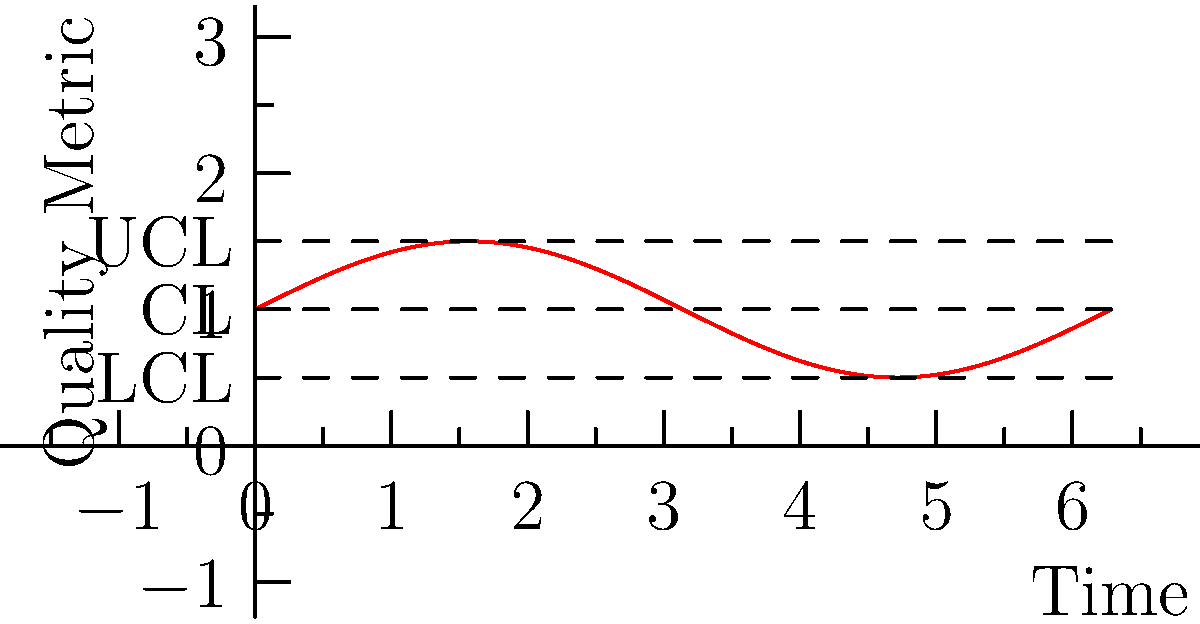A quality control chart for a new product line shows the variation in a key quality metric over time. The curve follows the function $f(x) = 0.5\sin(x) + 1$, where $x$ represents time in hours and $f(x)$ represents the quality metric. Calculate the area between the curve and the central line (CL) over one complete cycle (from 0 to $2\pi$ hours). How does this area relate to the process capability? To solve this problem, we'll follow these steps:

1) The area between the curve and the central line is given by the integral of the absolute difference between $f(x)$ and the central line value.

2) The central line (CL) is at $y = 1$.

3) The function to integrate is $|f(x) - 1| = |0.5\sin(x) + 1 - 1| = |0.5\sin(x)|$.

4) We need to integrate this over one cycle, from 0 to $2\pi$:

   $$A = \int_0^{2\pi} |0.5\sin(x)| dx$$

5) This integral can be solved by breaking it into two parts:
   
   $$A = 2 \int_0^{\pi} 0.5\sin(x) dx$$

6) Solving this integral:

   $$A = 2 \cdot (-0.5\cos(x))|_0^{\pi} = 2 \cdot (-0.5\cos(\pi) + 0.5\cos(0)) = 2 \cdot (0.5 + 0.5) = 2$$

7) The area is 2 square units.

8) This area represents the total deviation from the central line over one cycle. A smaller area would indicate less variation and better process capability. The ratio of this area to the area between the Upper Control Limit (UCL) and Lower Control Limit (LCL) could be used as a measure of process capability.
Answer: 2 square units; smaller area indicates better process capability 